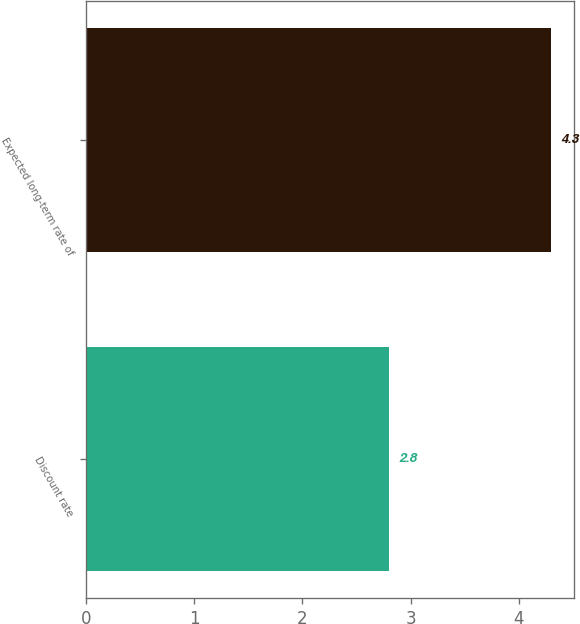Convert chart. <chart><loc_0><loc_0><loc_500><loc_500><bar_chart><fcel>Discount rate<fcel>Expected long-term rate of<nl><fcel>2.8<fcel>4.3<nl></chart> 